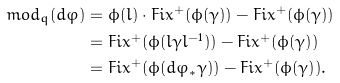Convert formula to latex. <formula><loc_0><loc_0><loc_500><loc_500>m o d _ { q } ( d \varphi ) & = \phi ( l ) \cdot F i x ^ { + } ( \phi ( \gamma ) ) - F i x ^ { + } ( \phi ( \gamma ) ) \\ & = F i x ^ { + } ( \phi ( l \gamma l ^ { - 1 } ) ) - F i x ^ { + } ( \phi ( \gamma ) ) \\ & = F i x ^ { + } ( \phi ( d \varphi _ { * } \gamma ) ) - F i x ^ { + } ( \phi ( \gamma ) ) .</formula> 